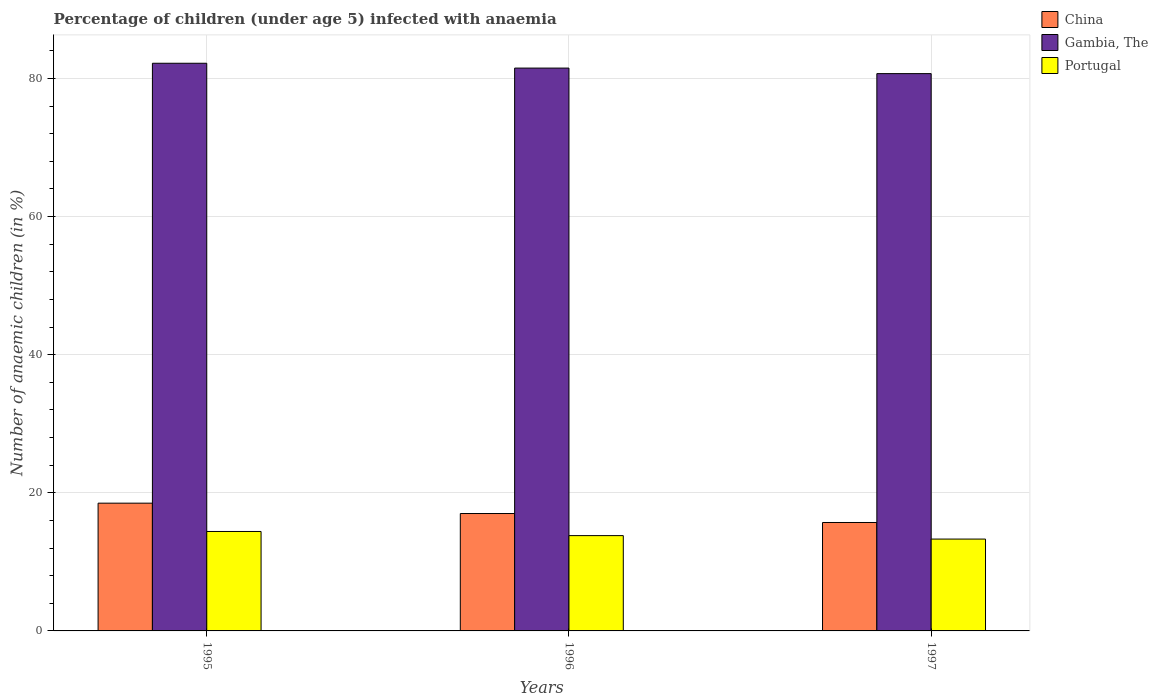How many different coloured bars are there?
Provide a short and direct response. 3. How many groups of bars are there?
Provide a short and direct response. 3. Are the number of bars on each tick of the X-axis equal?
Your response must be concise. Yes. How many bars are there on the 3rd tick from the left?
Ensure brevity in your answer.  3. How many bars are there on the 2nd tick from the right?
Make the answer very short. 3. Across all years, what is the maximum percentage of children infected with anaemia in in Portugal?
Provide a short and direct response. 14.4. Across all years, what is the minimum percentage of children infected with anaemia in in Portugal?
Ensure brevity in your answer.  13.3. In which year was the percentage of children infected with anaemia in in Gambia, The minimum?
Offer a terse response. 1997. What is the total percentage of children infected with anaemia in in Portugal in the graph?
Offer a terse response. 41.5. What is the difference between the percentage of children infected with anaemia in in Gambia, The in 1995 and that in 1996?
Provide a succinct answer. 0.7. What is the difference between the percentage of children infected with anaemia in in Portugal in 1997 and the percentage of children infected with anaemia in in Gambia, The in 1996?
Your answer should be compact. -68.2. What is the average percentage of children infected with anaemia in in China per year?
Provide a short and direct response. 17.07. In the year 1995, what is the difference between the percentage of children infected with anaemia in in China and percentage of children infected with anaemia in in Gambia, The?
Your answer should be compact. -63.7. What is the ratio of the percentage of children infected with anaemia in in Gambia, The in 1995 to that in 1996?
Offer a terse response. 1.01. Is the percentage of children infected with anaemia in in Portugal in 1995 less than that in 1996?
Your answer should be very brief. No. Is the difference between the percentage of children infected with anaemia in in China in 1996 and 1997 greater than the difference between the percentage of children infected with anaemia in in Gambia, The in 1996 and 1997?
Ensure brevity in your answer.  Yes. What is the difference between the highest and the second highest percentage of children infected with anaemia in in Portugal?
Offer a terse response. 0.6. What is the difference between the highest and the lowest percentage of children infected with anaemia in in China?
Give a very brief answer. 2.8. Is the sum of the percentage of children infected with anaemia in in Gambia, The in 1995 and 1997 greater than the maximum percentage of children infected with anaemia in in China across all years?
Keep it short and to the point. Yes. What does the 3rd bar from the left in 1995 represents?
Your response must be concise. Portugal. What is the difference between two consecutive major ticks on the Y-axis?
Ensure brevity in your answer.  20. Are the values on the major ticks of Y-axis written in scientific E-notation?
Keep it short and to the point. No. Where does the legend appear in the graph?
Offer a very short reply. Top right. What is the title of the graph?
Your answer should be very brief. Percentage of children (under age 5) infected with anaemia. Does "Switzerland" appear as one of the legend labels in the graph?
Make the answer very short. No. What is the label or title of the X-axis?
Offer a terse response. Years. What is the label or title of the Y-axis?
Offer a very short reply. Number of anaemic children (in %). What is the Number of anaemic children (in %) of China in 1995?
Offer a very short reply. 18.5. What is the Number of anaemic children (in %) in Gambia, The in 1995?
Provide a succinct answer. 82.2. What is the Number of anaemic children (in %) of Gambia, The in 1996?
Provide a succinct answer. 81.5. What is the Number of anaemic children (in %) in Portugal in 1996?
Your answer should be very brief. 13.8. What is the Number of anaemic children (in %) of Gambia, The in 1997?
Offer a very short reply. 80.7. What is the Number of anaemic children (in %) in Portugal in 1997?
Give a very brief answer. 13.3. Across all years, what is the maximum Number of anaemic children (in %) of China?
Make the answer very short. 18.5. Across all years, what is the maximum Number of anaemic children (in %) of Gambia, The?
Offer a very short reply. 82.2. Across all years, what is the maximum Number of anaemic children (in %) of Portugal?
Give a very brief answer. 14.4. Across all years, what is the minimum Number of anaemic children (in %) in Gambia, The?
Offer a very short reply. 80.7. Across all years, what is the minimum Number of anaemic children (in %) of Portugal?
Offer a terse response. 13.3. What is the total Number of anaemic children (in %) of China in the graph?
Your response must be concise. 51.2. What is the total Number of anaemic children (in %) of Gambia, The in the graph?
Make the answer very short. 244.4. What is the total Number of anaemic children (in %) in Portugal in the graph?
Your answer should be very brief. 41.5. What is the difference between the Number of anaemic children (in %) of China in 1995 and that in 1996?
Keep it short and to the point. 1.5. What is the difference between the Number of anaemic children (in %) in Gambia, The in 1995 and that in 1996?
Provide a short and direct response. 0.7. What is the difference between the Number of anaemic children (in %) of Portugal in 1995 and that in 1996?
Make the answer very short. 0.6. What is the difference between the Number of anaemic children (in %) of Portugal in 1995 and that in 1997?
Provide a short and direct response. 1.1. What is the difference between the Number of anaemic children (in %) of Portugal in 1996 and that in 1997?
Ensure brevity in your answer.  0.5. What is the difference between the Number of anaemic children (in %) in China in 1995 and the Number of anaemic children (in %) in Gambia, The in 1996?
Your answer should be very brief. -63. What is the difference between the Number of anaemic children (in %) in China in 1995 and the Number of anaemic children (in %) in Portugal in 1996?
Ensure brevity in your answer.  4.7. What is the difference between the Number of anaemic children (in %) of Gambia, The in 1995 and the Number of anaemic children (in %) of Portugal in 1996?
Make the answer very short. 68.4. What is the difference between the Number of anaemic children (in %) of China in 1995 and the Number of anaemic children (in %) of Gambia, The in 1997?
Make the answer very short. -62.2. What is the difference between the Number of anaemic children (in %) in China in 1995 and the Number of anaemic children (in %) in Portugal in 1997?
Give a very brief answer. 5.2. What is the difference between the Number of anaemic children (in %) in Gambia, The in 1995 and the Number of anaemic children (in %) in Portugal in 1997?
Offer a terse response. 68.9. What is the difference between the Number of anaemic children (in %) in China in 1996 and the Number of anaemic children (in %) in Gambia, The in 1997?
Ensure brevity in your answer.  -63.7. What is the difference between the Number of anaemic children (in %) in Gambia, The in 1996 and the Number of anaemic children (in %) in Portugal in 1997?
Make the answer very short. 68.2. What is the average Number of anaemic children (in %) in China per year?
Offer a terse response. 17.07. What is the average Number of anaemic children (in %) of Gambia, The per year?
Provide a short and direct response. 81.47. What is the average Number of anaemic children (in %) of Portugal per year?
Your response must be concise. 13.83. In the year 1995, what is the difference between the Number of anaemic children (in %) in China and Number of anaemic children (in %) in Gambia, The?
Your response must be concise. -63.7. In the year 1995, what is the difference between the Number of anaemic children (in %) in China and Number of anaemic children (in %) in Portugal?
Offer a terse response. 4.1. In the year 1995, what is the difference between the Number of anaemic children (in %) of Gambia, The and Number of anaemic children (in %) of Portugal?
Keep it short and to the point. 67.8. In the year 1996, what is the difference between the Number of anaemic children (in %) in China and Number of anaemic children (in %) in Gambia, The?
Your response must be concise. -64.5. In the year 1996, what is the difference between the Number of anaemic children (in %) in China and Number of anaemic children (in %) in Portugal?
Offer a terse response. 3.2. In the year 1996, what is the difference between the Number of anaemic children (in %) of Gambia, The and Number of anaemic children (in %) of Portugal?
Offer a terse response. 67.7. In the year 1997, what is the difference between the Number of anaemic children (in %) in China and Number of anaemic children (in %) in Gambia, The?
Keep it short and to the point. -65. In the year 1997, what is the difference between the Number of anaemic children (in %) of Gambia, The and Number of anaemic children (in %) of Portugal?
Keep it short and to the point. 67.4. What is the ratio of the Number of anaemic children (in %) in China in 1995 to that in 1996?
Offer a terse response. 1.09. What is the ratio of the Number of anaemic children (in %) of Gambia, The in 1995 to that in 1996?
Offer a terse response. 1.01. What is the ratio of the Number of anaemic children (in %) of Portugal in 1995 to that in 1996?
Offer a very short reply. 1.04. What is the ratio of the Number of anaemic children (in %) of China in 1995 to that in 1997?
Offer a very short reply. 1.18. What is the ratio of the Number of anaemic children (in %) of Gambia, The in 1995 to that in 1997?
Provide a succinct answer. 1.02. What is the ratio of the Number of anaemic children (in %) of Portugal in 1995 to that in 1997?
Provide a short and direct response. 1.08. What is the ratio of the Number of anaemic children (in %) of China in 1996 to that in 1997?
Your answer should be very brief. 1.08. What is the ratio of the Number of anaemic children (in %) of Gambia, The in 1996 to that in 1997?
Keep it short and to the point. 1.01. What is the ratio of the Number of anaemic children (in %) of Portugal in 1996 to that in 1997?
Your answer should be compact. 1.04. What is the difference between the highest and the second highest Number of anaemic children (in %) in Gambia, The?
Keep it short and to the point. 0.7. What is the difference between the highest and the lowest Number of anaemic children (in %) of Gambia, The?
Give a very brief answer. 1.5. What is the difference between the highest and the lowest Number of anaemic children (in %) in Portugal?
Provide a short and direct response. 1.1. 